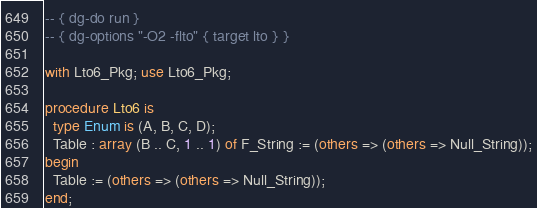Convert code to text. <code><loc_0><loc_0><loc_500><loc_500><_Ada_>-- { dg-do run }
-- { dg-options "-O2 -flto" { target lto } }

with Lto6_Pkg; use Lto6_Pkg;

procedure Lto6 is
  type Enum is (A, B, C, D);
  Table : array (B .. C, 1 .. 1) of F_String := (others => (others => Null_String));
begin
  Table := (others => (others => Null_String));
end;
</code> 